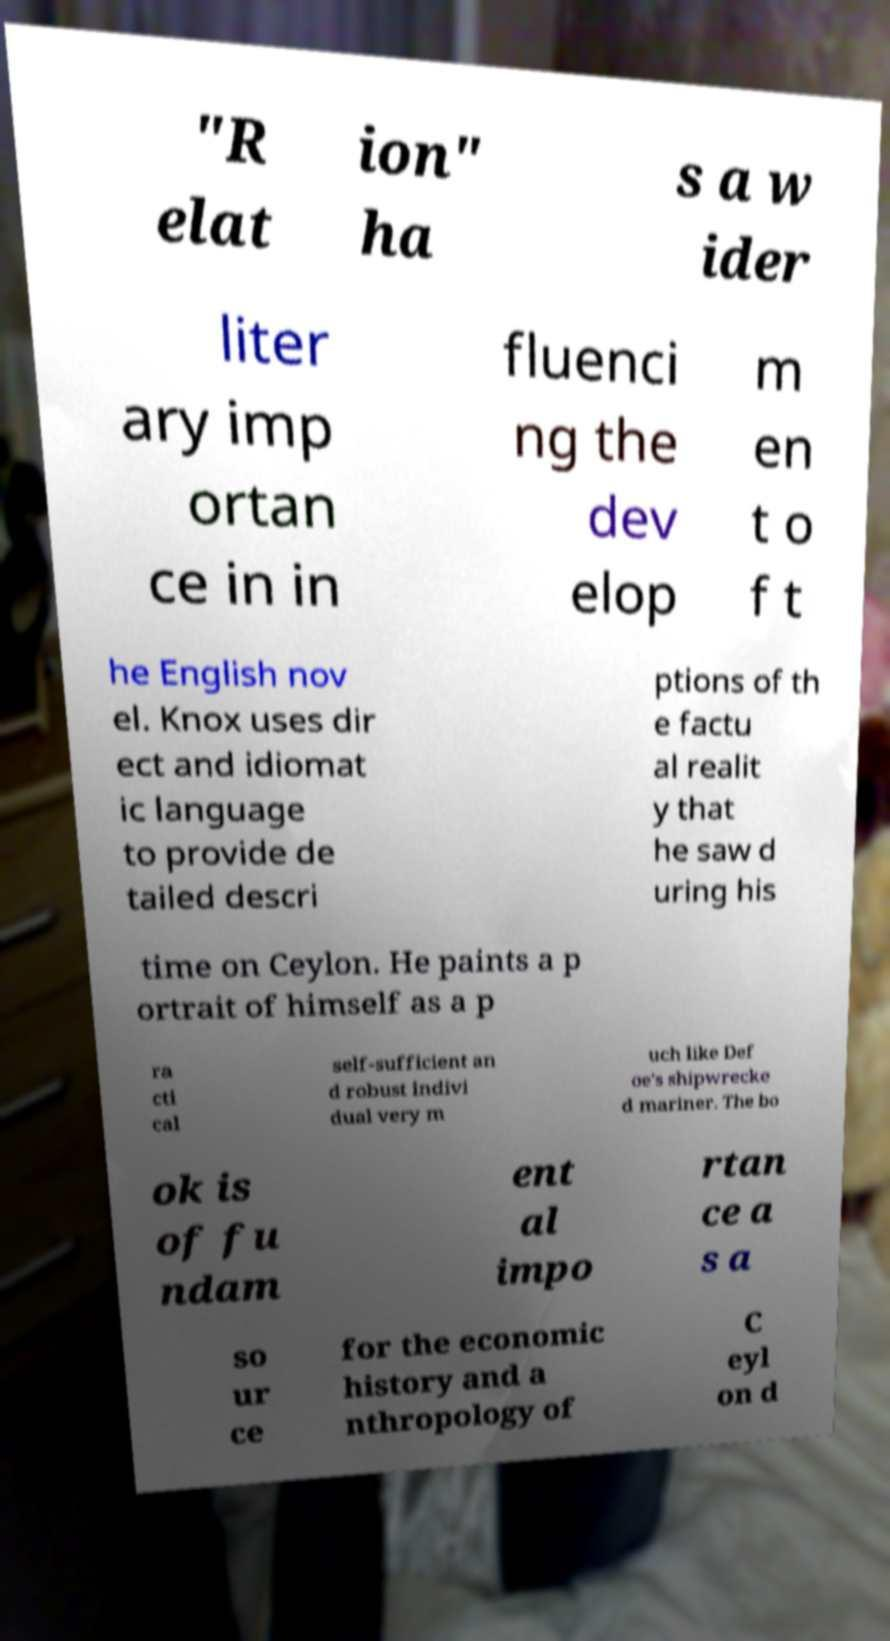There's text embedded in this image that I need extracted. Can you transcribe it verbatim? "R elat ion" ha s a w ider liter ary imp ortan ce in in fluenci ng the dev elop m en t o f t he English nov el. Knox uses dir ect and idiomat ic language to provide de tailed descri ptions of th e factu al realit y that he saw d uring his time on Ceylon. He paints a p ortrait of himself as a p ra cti cal self-sufficient an d robust indivi dual very m uch like Def oe's shipwrecke d mariner. The bo ok is of fu ndam ent al impo rtan ce a s a so ur ce for the economic history and a nthropology of C eyl on d 